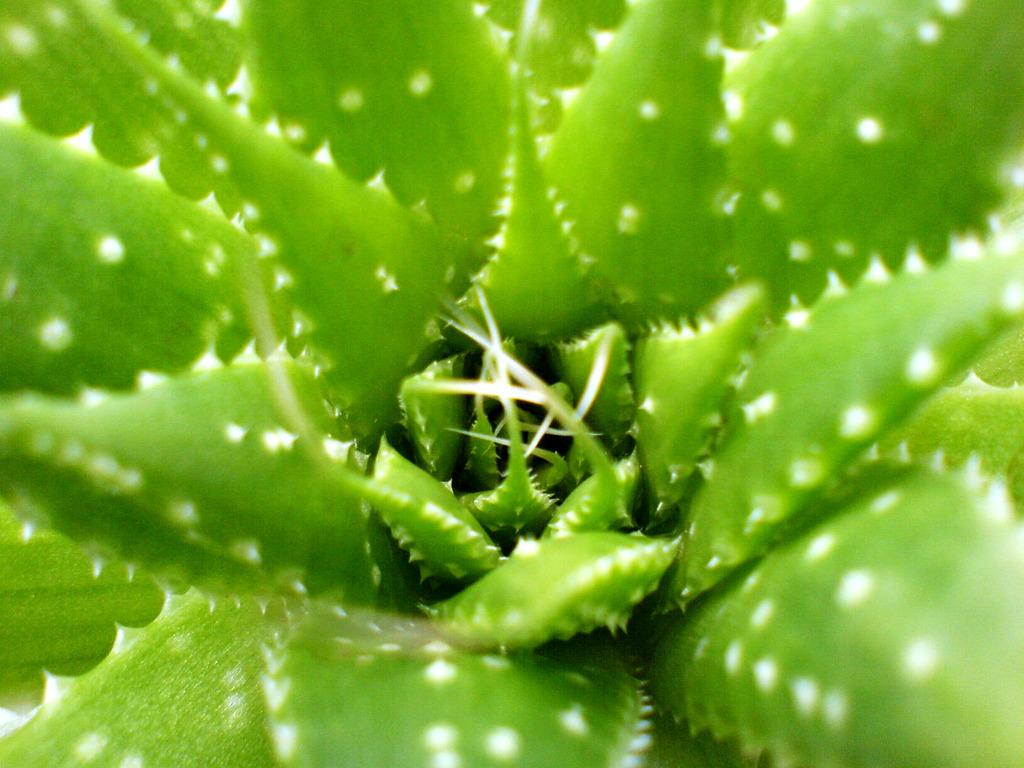What type of plant is featured in the image? There are aloe vera leaves in the image. What type of hook is attached to the brass tub in the image? There is no hook or brass tub present in the image; it only features aloe vera leaves. 